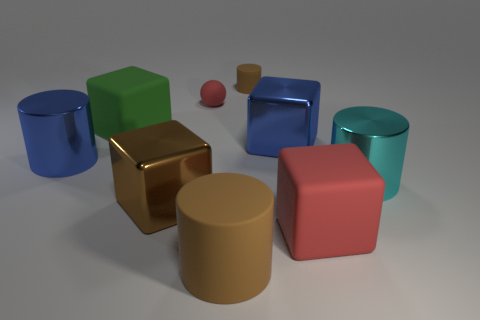Subtract all blue cylinders. Subtract all green cubes. How many cylinders are left? 3 Add 1 tiny purple metallic cylinders. How many objects exist? 10 Subtract all cylinders. How many objects are left? 5 Subtract 0 purple blocks. How many objects are left? 9 Subtract all large red objects. Subtract all matte spheres. How many objects are left? 7 Add 4 red matte balls. How many red matte balls are left? 5 Add 1 big red spheres. How many big red spheres exist? 1 